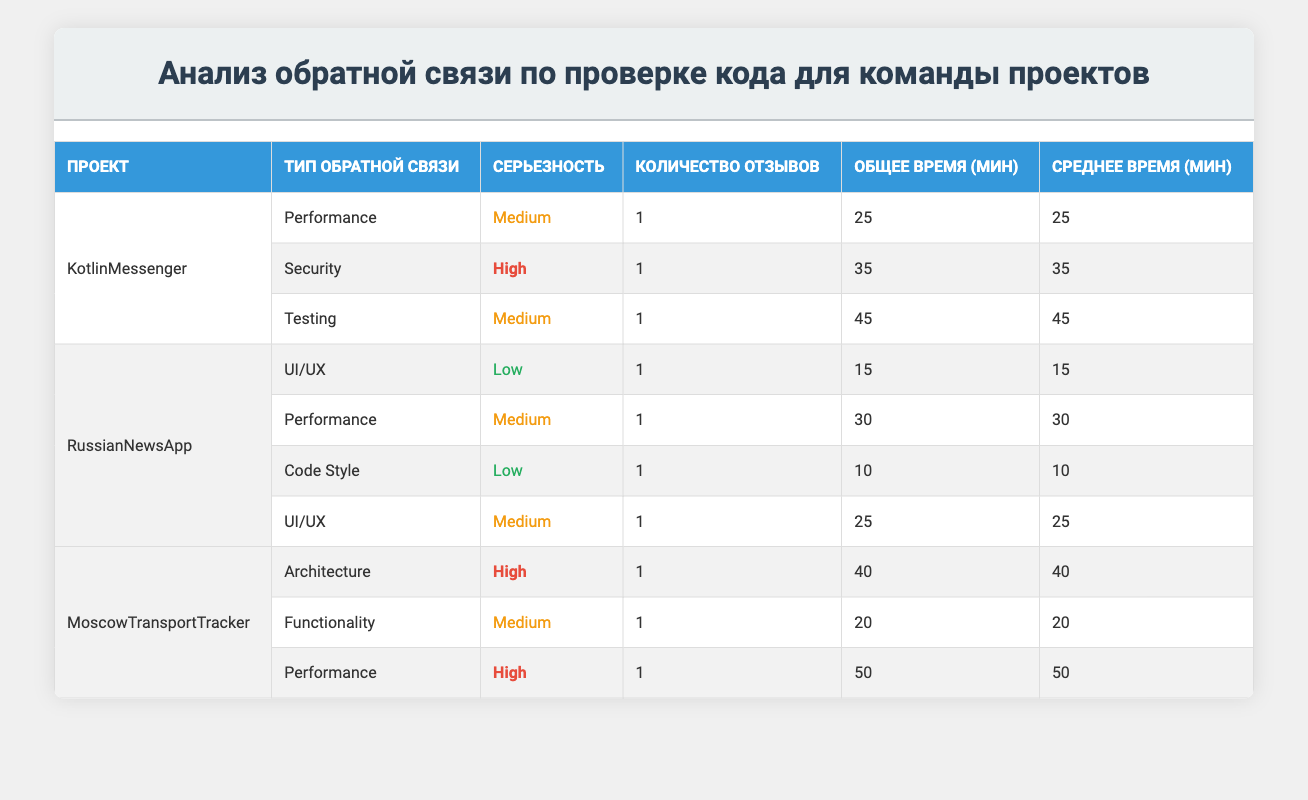What is the total time spent on code reviews for the KotlinMessenger project? The table shows that the total time spent on code reviews for the KotlinMessenger project is the sum of the times for all feedback types listed under it: 25 (Performance) + 35 (Security) + 45 (Testing) = 105.
Answer: 105 Which feedback type has the highest severity for the RussianNewsApp project? Looking at the RussianNewsApp rows, we see that the feedback types are UI/UX (Low), Performance (Medium), and Code Style (Low). The maximum severity level amongst these is "Medium" for Performance.
Answer: Performance Is there any feedback related to Security in the MoscowTransportTracker project? Reviewing the feedback types listed for the MoscowTransportTracker project, we see Architecture (High), Functionality (Medium), and Performance (High). Security is not mentioned, so the answer is no.
Answer: No What is the average time spent on reviews for the RussianNewsApp? First, we find the total time spent on reviews for RussianNewsApp: 15 (UI/UX) + 30 (Performance) + 10 (Code Style) + 25 (UI/UX) = 80 minutes. There are 4 reviews, so we calculate the average: 80/4 = 20.
Answer: 20 Which project has the highest total time spent on code reviews, and what is that time? By summing the total time spent on each project, we find: KotlinMessenger = 105, RussianNewsApp = 80, and MoscowTransportTracker = 110 (40 + 20 + 50). The highest total is for MoscowTransportTracker at 110 minutes.
Answer: MoscowTransportTracker, 110 Which reviewer provided feedback for the highest number of reviews? Checking the reviewers, Anton appears 4 times (for KotlinMessenger and RussianNewsApp), Elena once, Dmitry once, Olga once, Sergei once, Maria once, and Ivan once. Therefore, Anton provided feedback for the highest number of reviews.
Answer: Anton Is there any review feedback marked as High severity for the KotlinMessenger project? The table shows that for KotlinMessenger, the feedback types are Performance (Medium), Security (High), and Testing (Medium). There is indeed a feedback marked as High severity.
Answer: Yes What is the total number of feedback types for the MoscowTransportTracker project? The feedback types listed for MoscowTransportTracker are Architecture, Functionality, and Performance. There are 3 distinct feedback types for this project.
Answer: 3 